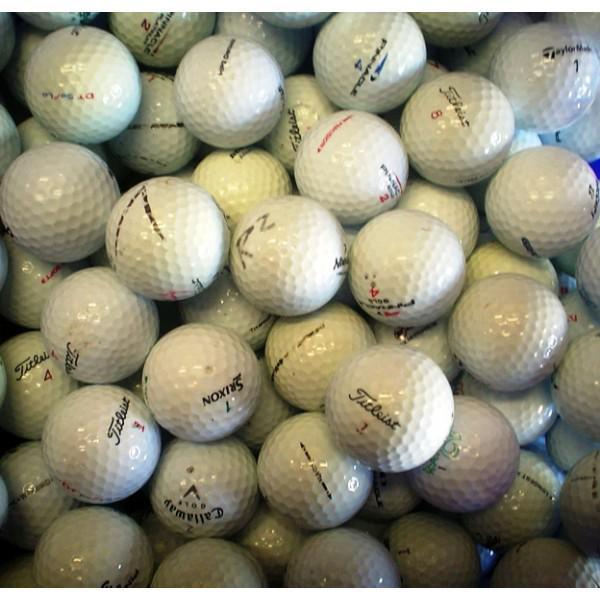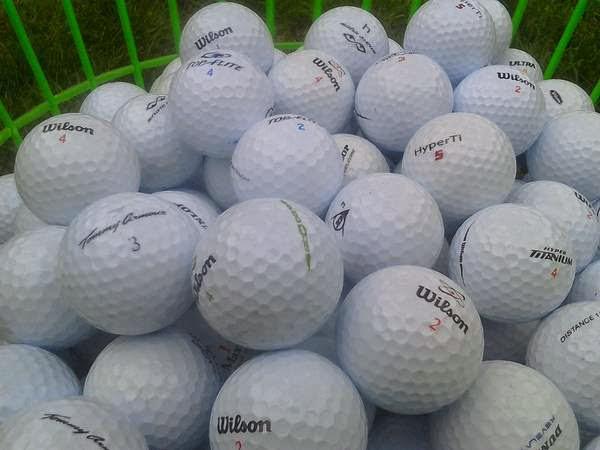The first image is the image on the left, the second image is the image on the right. Examine the images to the left and right. Is the description "An image shows an angled row of three white golf balls on tees on green carpet." accurate? Answer yes or no. No. The first image is the image on the left, the second image is the image on the right. Assess this claim about the two images: "Three balls are on tees in one of the images.". Correct or not? Answer yes or no. No. 